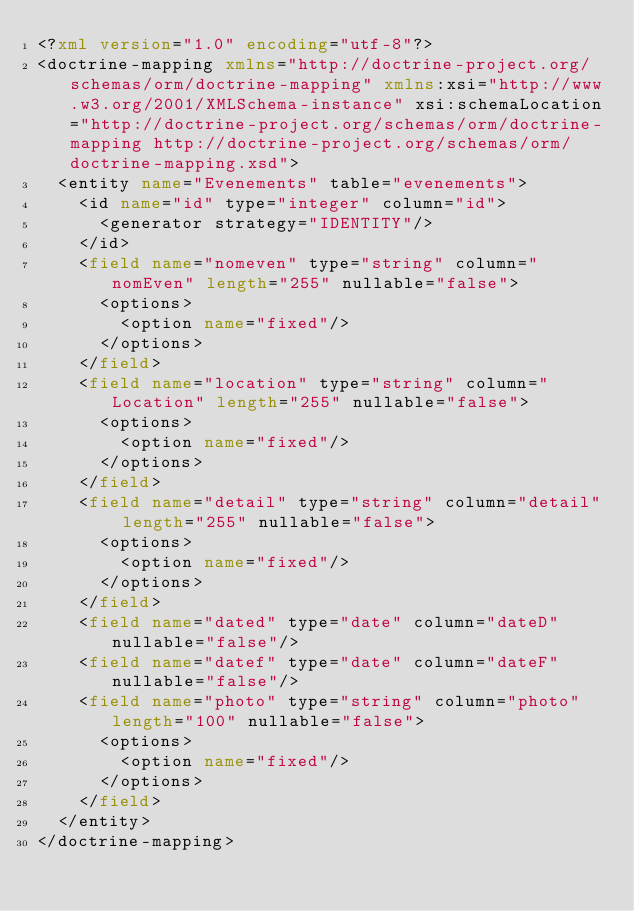<code> <loc_0><loc_0><loc_500><loc_500><_XML_><?xml version="1.0" encoding="utf-8"?>
<doctrine-mapping xmlns="http://doctrine-project.org/schemas/orm/doctrine-mapping" xmlns:xsi="http://www.w3.org/2001/XMLSchema-instance" xsi:schemaLocation="http://doctrine-project.org/schemas/orm/doctrine-mapping http://doctrine-project.org/schemas/orm/doctrine-mapping.xsd">
  <entity name="Evenements" table="evenements">
    <id name="id" type="integer" column="id">
      <generator strategy="IDENTITY"/>
    </id>
    <field name="nomeven" type="string" column="nomEven" length="255" nullable="false">
      <options>
        <option name="fixed"/>
      </options>
    </field>
    <field name="location" type="string" column="Location" length="255" nullable="false">
      <options>
        <option name="fixed"/>
      </options>
    </field>
    <field name="detail" type="string" column="detail" length="255" nullable="false">
      <options>
        <option name="fixed"/>
      </options>
    </field>
    <field name="dated" type="date" column="dateD" nullable="false"/>
    <field name="datef" type="date" column="dateF" nullable="false"/>
    <field name="photo" type="string" column="photo" length="100" nullable="false">
      <options>
        <option name="fixed"/>
      </options>
    </field>
  </entity>
</doctrine-mapping>
</code> 